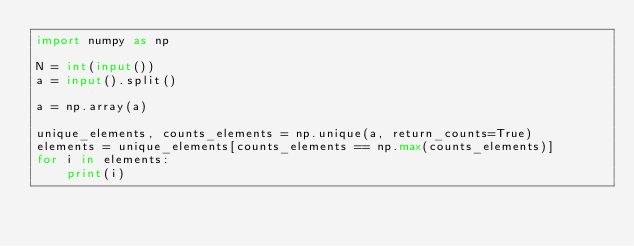Convert code to text. <code><loc_0><loc_0><loc_500><loc_500><_Python_>import numpy as np

N = int(input())
a = input().split()

a = np.array(a)

unique_elements, counts_elements = np.unique(a, return_counts=True)
elements = unique_elements[counts_elements == np.max(counts_elements)]
for i in elements:
    print(i)
</code> 